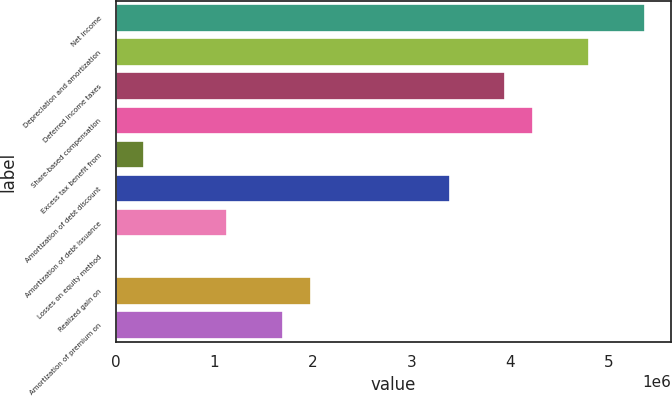Convert chart to OTSL. <chart><loc_0><loc_0><loc_500><loc_500><bar_chart><fcel>Net income<fcel>Depreciation and amortization<fcel>Deferred income taxes<fcel>Share-based compensation<fcel>Excess tax benefit from<fcel>Amortization of debt discount<fcel>Amortization of debt issuance<fcel>Losses on equity method<fcel>Realized gain on<fcel>Amortization of premium on<nl><fcel>5.36573e+06<fcel>4.80095e+06<fcel>3.95379e+06<fcel>4.23617e+06<fcel>282734<fcel>3.38901e+06<fcel>1.1299e+06<fcel>345<fcel>1.97707e+06<fcel>1.69468e+06<nl></chart> 